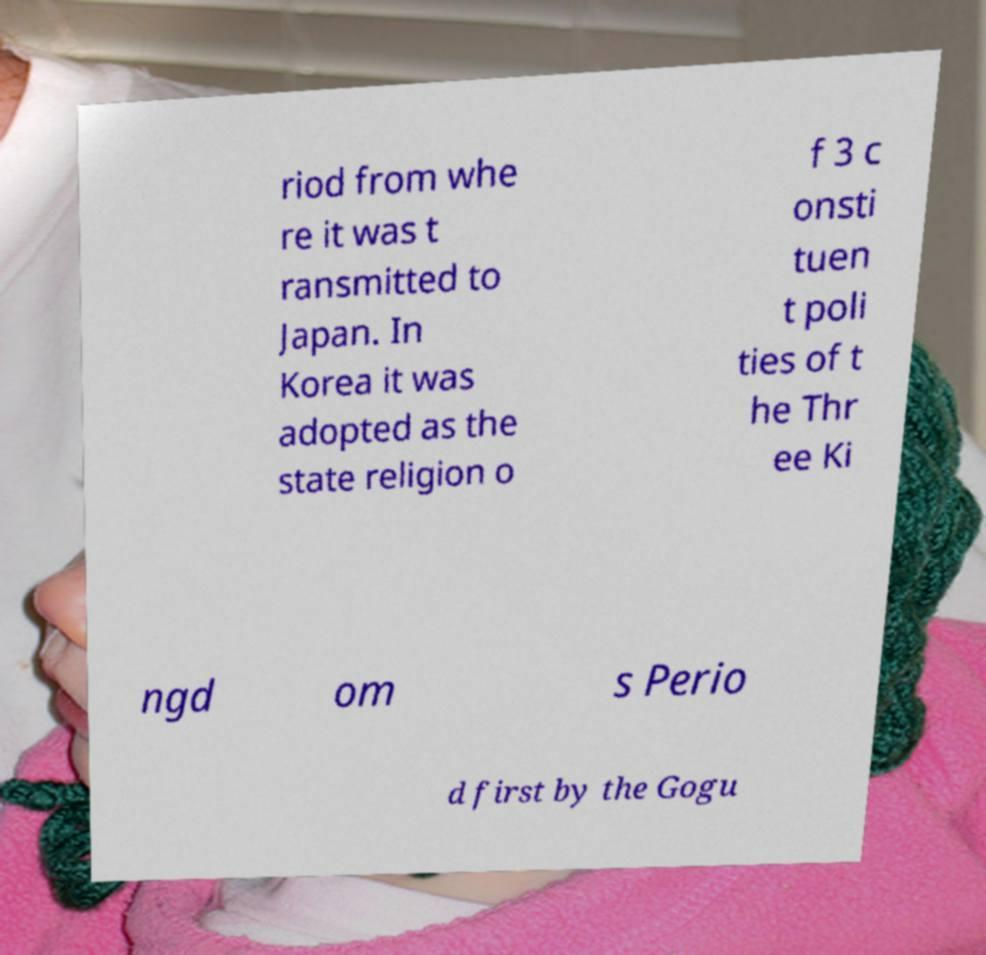Please identify and transcribe the text found in this image. riod from whe re it was t ransmitted to Japan. In Korea it was adopted as the state religion o f 3 c onsti tuen t poli ties of t he Thr ee Ki ngd om s Perio d first by the Gogu 